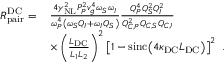Convert formula to latex. <formula><loc_0><loc_0><loc_500><loc_500>\begin{array} { r l } { R _ { p a i r } ^ { D C } = \, } & { \frac { 4 \gamma _ { N L } ^ { 2 } P _ { P } ^ { 2 } v _ { g } ^ { 4 } \omega _ { S } \omega _ { I } } { \omega _ { P } ^ { 4 } \left ( \omega _ { S } Q _ { I } + \omega _ { I } Q _ { S } \right ) } \frac { Q _ { P } ^ { 4 } Q _ { S } ^ { 2 } Q _ { I } ^ { 2 } } { Q _ { C , P } ^ { 2 } Q _ { C , S } Q _ { C , I } } } \\ & { \times \left ( \frac { L _ { D C } } { L _ { 1 } L _ { 2 } } \right ) ^ { 2 } \left [ 1 - \sin c \, \left ( 4 \kappa _ { D C } L _ { D C } \right ) \right ] ^ { 2 } \ . } \end{array}</formula> 